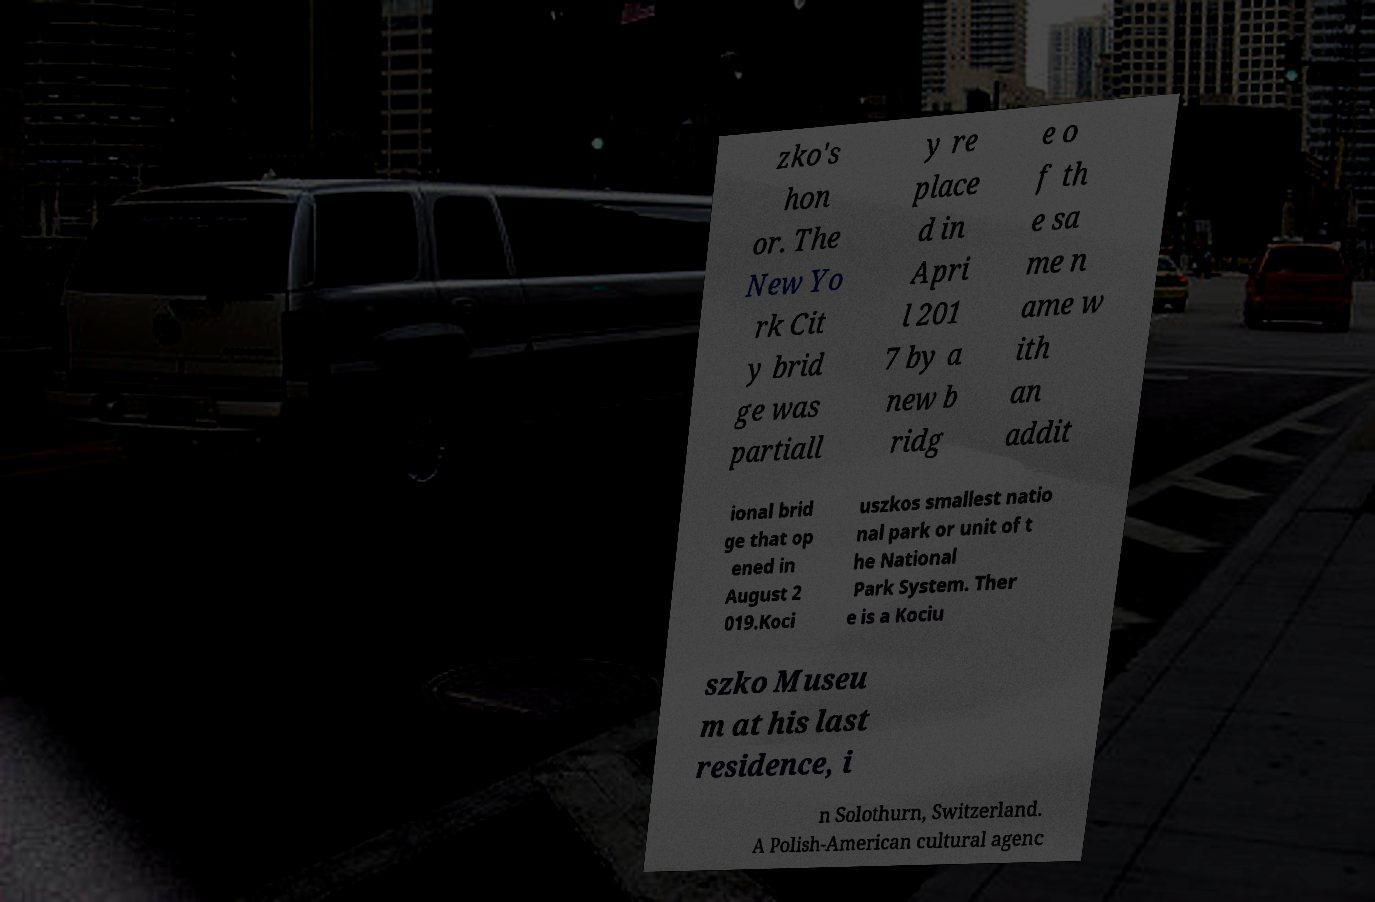What messages or text are displayed in this image? I need them in a readable, typed format. zko's hon or. The New Yo rk Cit y brid ge was partiall y re place d in Apri l 201 7 by a new b ridg e o f th e sa me n ame w ith an addit ional brid ge that op ened in August 2 019.Koci uszkos smallest natio nal park or unit of t he National Park System. Ther e is a Kociu szko Museu m at his last residence, i n Solothurn, Switzerland. A Polish-American cultural agenc 